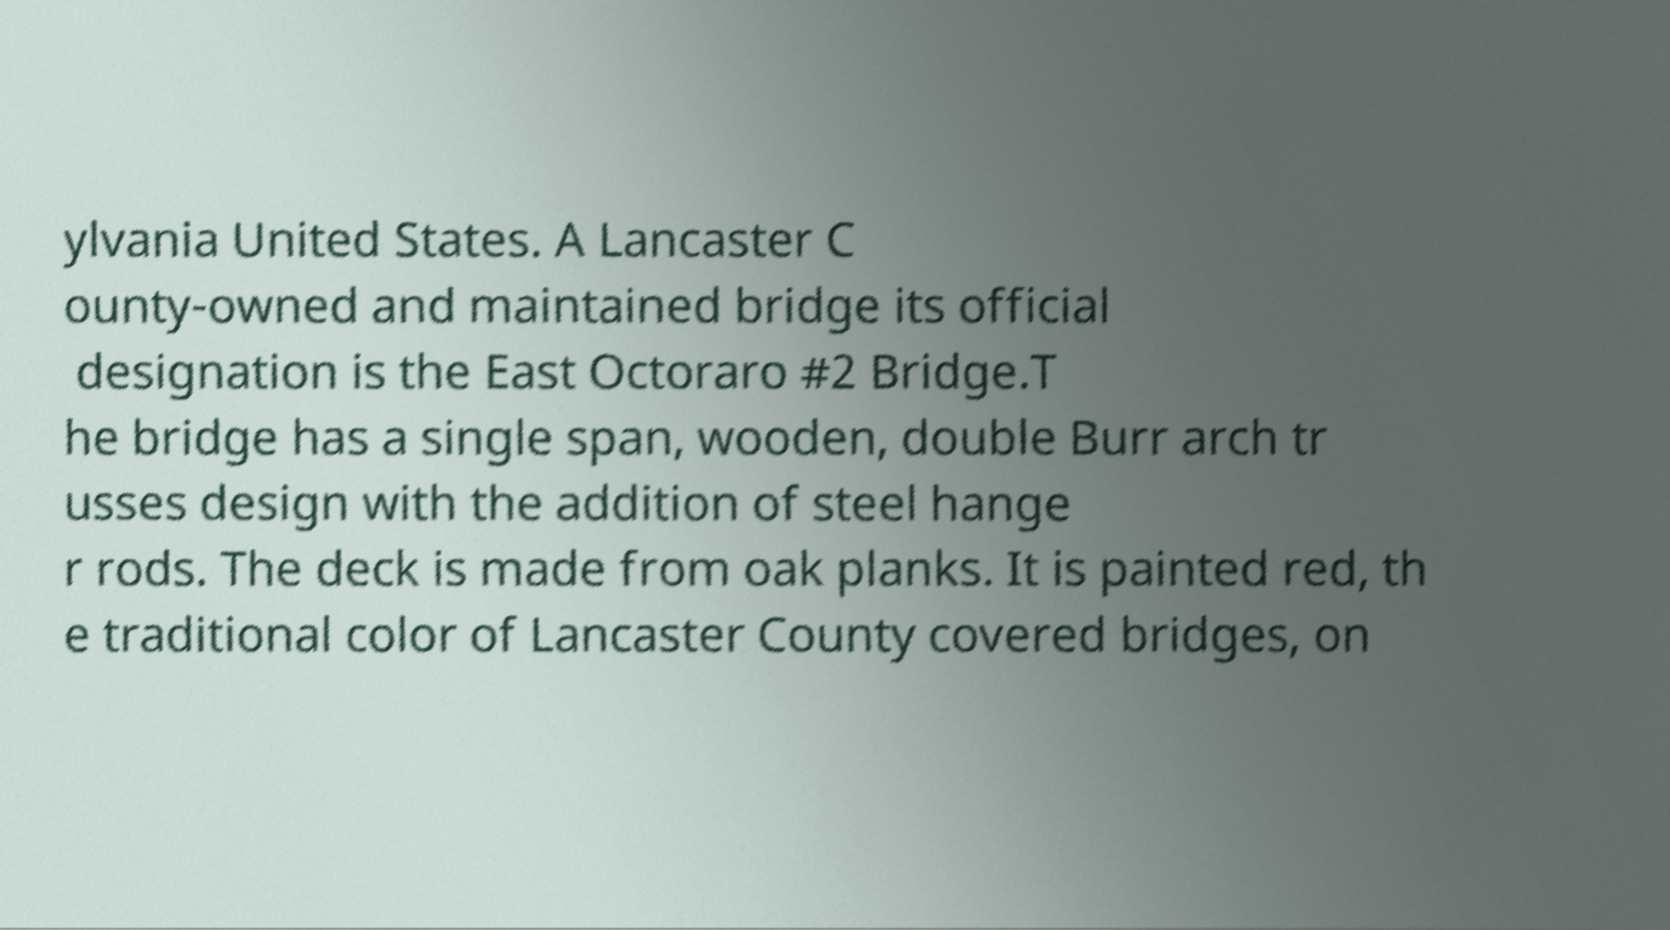Can you accurately transcribe the text from the provided image for me? ylvania United States. A Lancaster C ounty-owned and maintained bridge its official designation is the East Octoraro #2 Bridge.T he bridge has a single span, wooden, double Burr arch tr usses design with the addition of steel hange r rods. The deck is made from oak planks. It is painted red, th e traditional color of Lancaster County covered bridges, on 